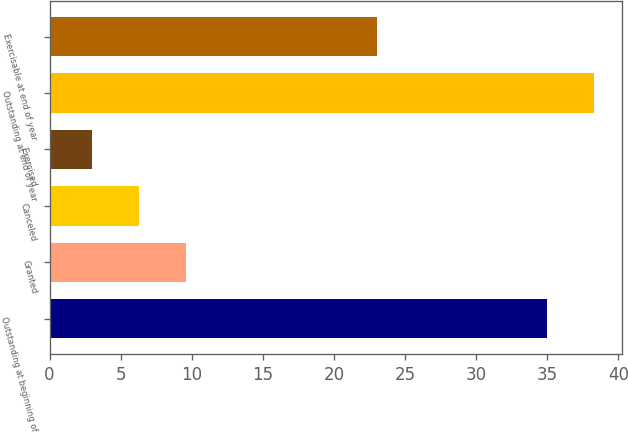Convert chart to OTSL. <chart><loc_0><loc_0><loc_500><loc_500><bar_chart><fcel>Outstanding at beginning of<fcel>Granted<fcel>Canceled<fcel>Exercised<fcel>Outstanding at end of year<fcel>Exercisable at end of year<nl><fcel>35<fcel>9.6<fcel>6.3<fcel>3<fcel>38.3<fcel>23<nl></chart> 